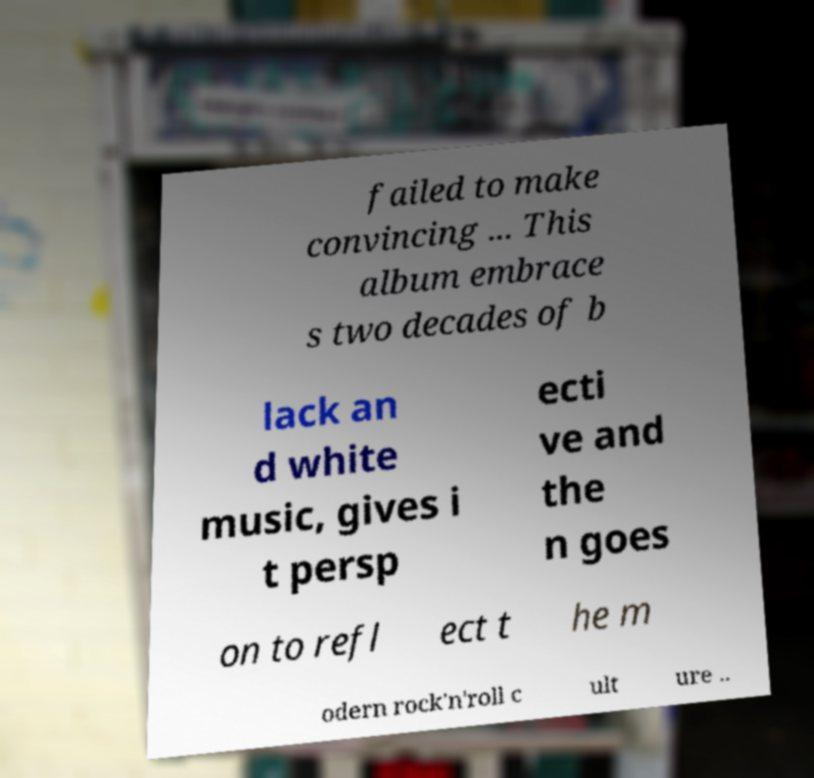Can you read and provide the text displayed in the image?This photo seems to have some interesting text. Can you extract and type it out for me? failed to make convincing ... This album embrace s two decades of b lack an d white music, gives i t persp ecti ve and the n goes on to refl ect t he m odern rock'n'roll c ult ure .. 